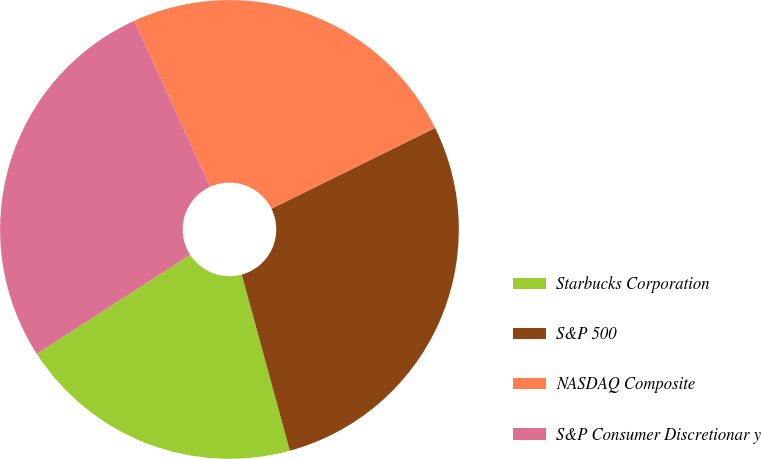Convert chart. <chart><loc_0><loc_0><loc_500><loc_500><pie_chart><fcel>Starbucks Corporation<fcel>S&P 500<fcel>NASDAQ Composite<fcel>S&P Consumer Discretionar y<nl><fcel>20.11%<fcel>28.06%<fcel>24.51%<fcel>27.32%<nl></chart> 